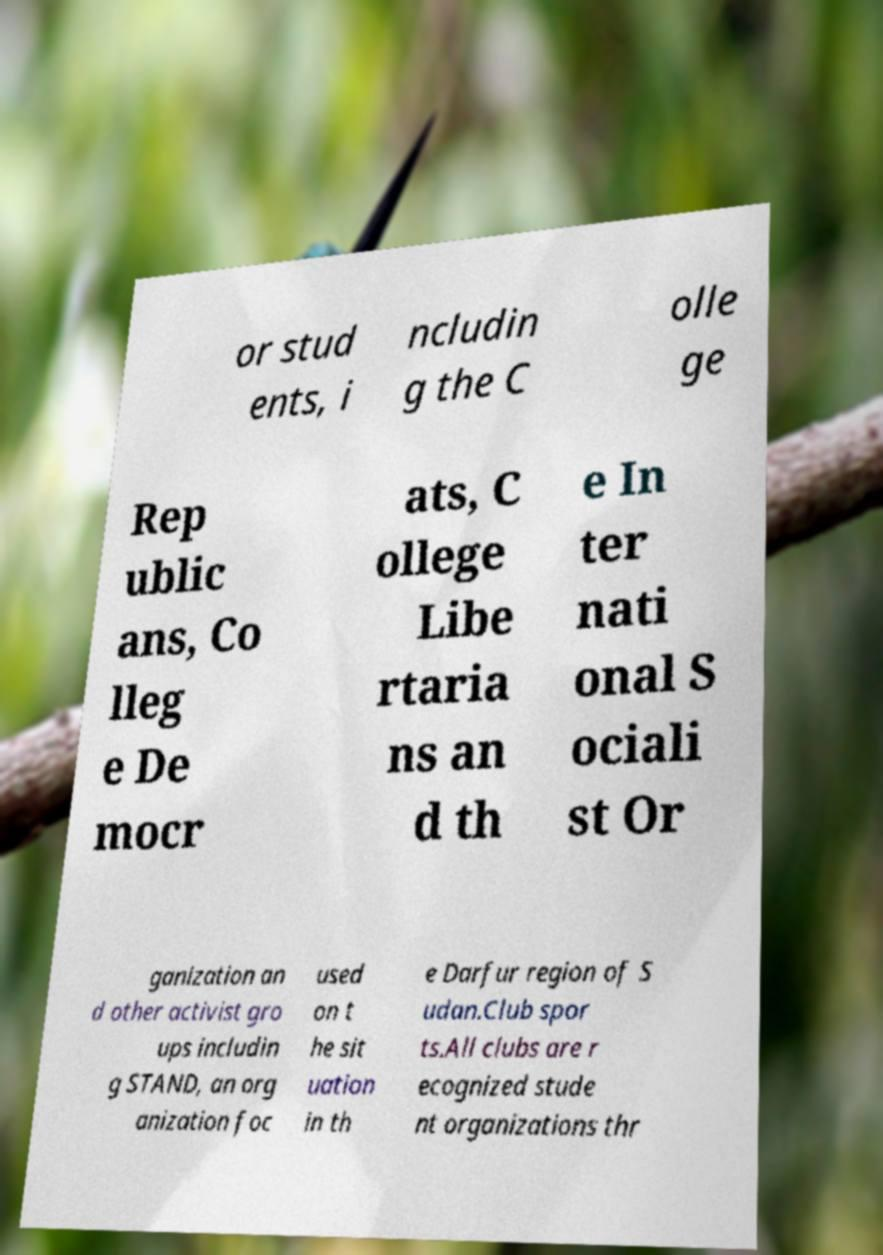There's text embedded in this image that I need extracted. Can you transcribe it verbatim? or stud ents, i ncludin g the C olle ge Rep ublic ans, Co lleg e De mocr ats, C ollege Libe rtaria ns an d th e In ter nati onal S ociali st Or ganization an d other activist gro ups includin g STAND, an org anization foc used on t he sit uation in th e Darfur region of S udan.Club spor ts.All clubs are r ecognized stude nt organizations thr 